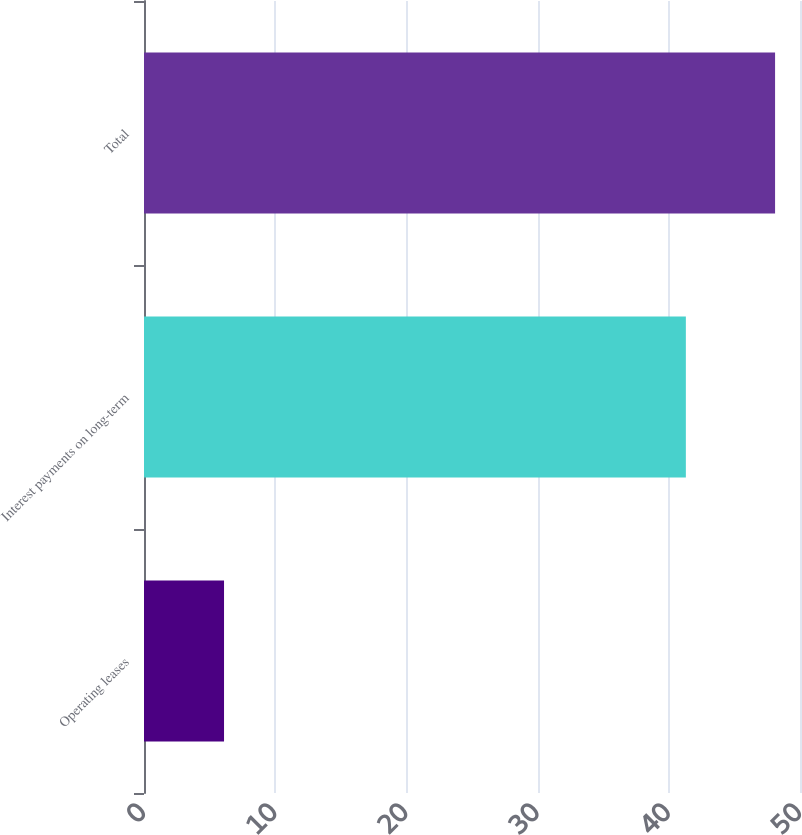Convert chart. <chart><loc_0><loc_0><loc_500><loc_500><bar_chart><fcel>Operating leases<fcel>Interest payments on long-term<fcel>Total<nl><fcel>6.1<fcel>41.3<fcel>48.1<nl></chart> 